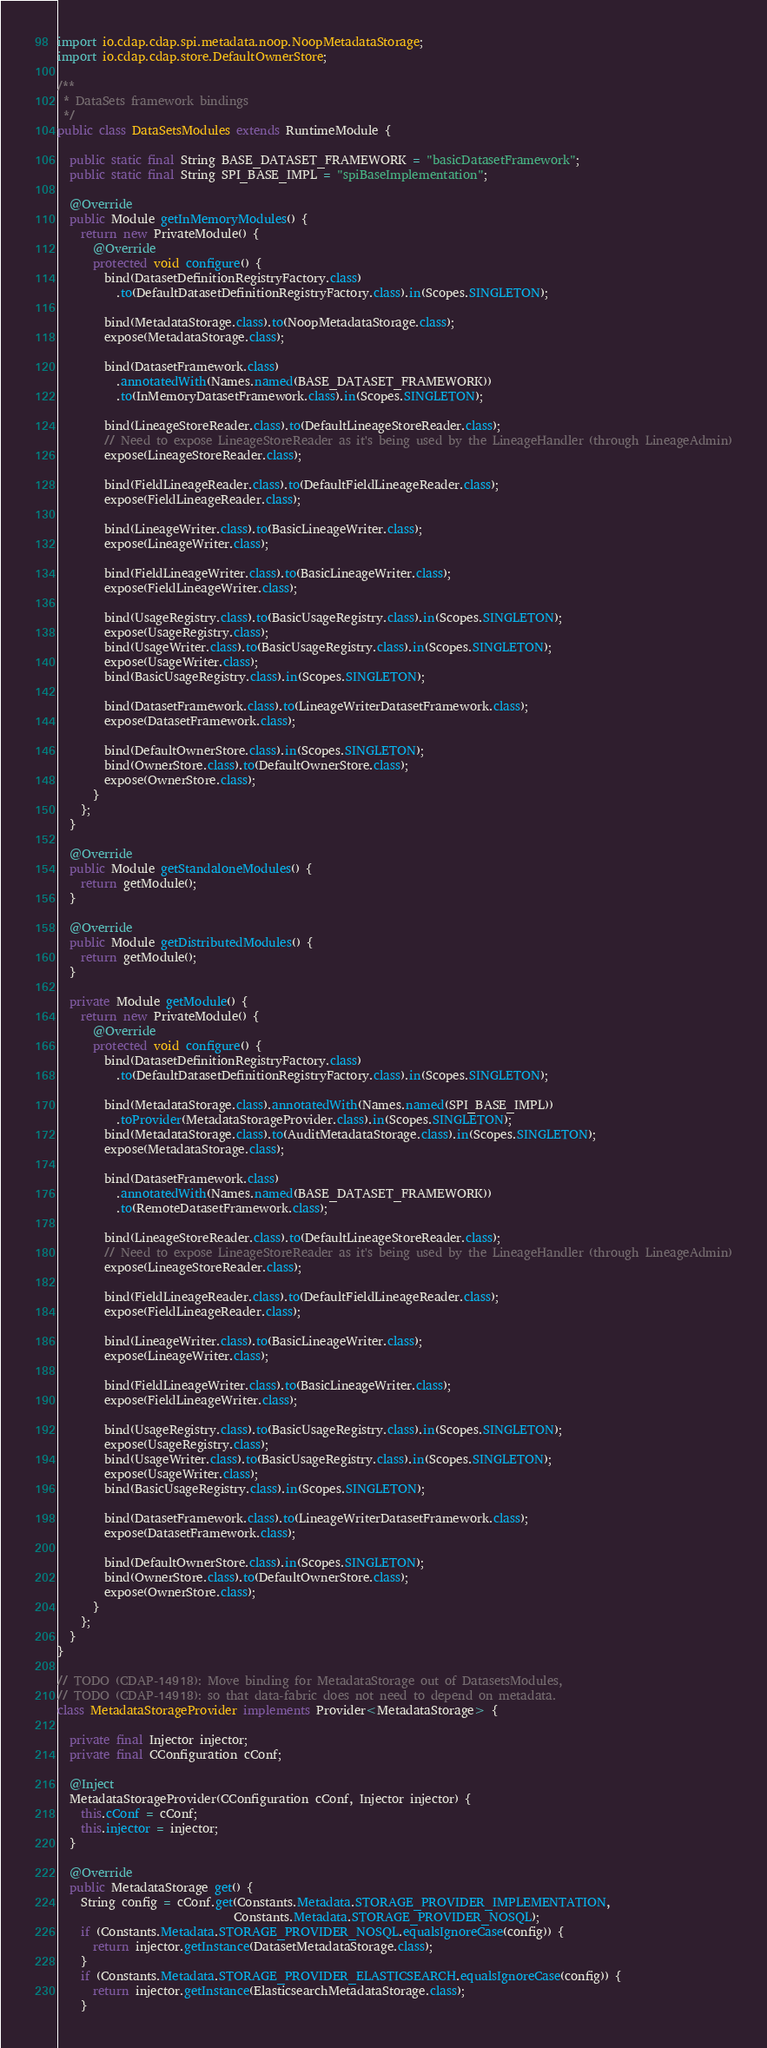Convert code to text. <code><loc_0><loc_0><loc_500><loc_500><_Java_>import io.cdap.cdap.spi.metadata.noop.NoopMetadataStorage;
import io.cdap.cdap.store.DefaultOwnerStore;

/**
 * DataSets framework bindings
 */
public class DataSetsModules extends RuntimeModule {

  public static final String BASE_DATASET_FRAMEWORK = "basicDatasetFramework";
  public static final String SPI_BASE_IMPL = "spiBaseImplementation";

  @Override
  public Module getInMemoryModules() {
    return new PrivateModule() {
      @Override
      protected void configure() {
        bind(DatasetDefinitionRegistryFactory.class)
          .to(DefaultDatasetDefinitionRegistryFactory.class).in(Scopes.SINGLETON);

        bind(MetadataStorage.class).to(NoopMetadataStorage.class);
        expose(MetadataStorage.class);

        bind(DatasetFramework.class)
          .annotatedWith(Names.named(BASE_DATASET_FRAMEWORK))
          .to(InMemoryDatasetFramework.class).in(Scopes.SINGLETON);

        bind(LineageStoreReader.class).to(DefaultLineageStoreReader.class);
        // Need to expose LineageStoreReader as it's being used by the LineageHandler (through LineageAdmin)
        expose(LineageStoreReader.class);

        bind(FieldLineageReader.class).to(DefaultFieldLineageReader.class);
        expose(FieldLineageReader.class);

        bind(LineageWriter.class).to(BasicLineageWriter.class);
        expose(LineageWriter.class);

        bind(FieldLineageWriter.class).to(BasicLineageWriter.class);
        expose(FieldLineageWriter.class);

        bind(UsageRegistry.class).to(BasicUsageRegistry.class).in(Scopes.SINGLETON);
        expose(UsageRegistry.class);
        bind(UsageWriter.class).to(BasicUsageRegistry.class).in(Scopes.SINGLETON);
        expose(UsageWriter.class);
        bind(BasicUsageRegistry.class).in(Scopes.SINGLETON);

        bind(DatasetFramework.class).to(LineageWriterDatasetFramework.class);
        expose(DatasetFramework.class);

        bind(DefaultOwnerStore.class).in(Scopes.SINGLETON);
        bind(OwnerStore.class).to(DefaultOwnerStore.class);
        expose(OwnerStore.class);
      }
    };
  }

  @Override
  public Module getStandaloneModules() {
    return getModule();
  }

  @Override
  public Module getDistributedModules() {
    return getModule();
  }

  private Module getModule() {
    return new PrivateModule() {
      @Override
      protected void configure() {
        bind(DatasetDefinitionRegistryFactory.class)
          .to(DefaultDatasetDefinitionRegistryFactory.class).in(Scopes.SINGLETON);

        bind(MetadataStorage.class).annotatedWith(Names.named(SPI_BASE_IMPL))
          .toProvider(MetadataStorageProvider.class).in(Scopes.SINGLETON);
        bind(MetadataStorage.class).to(AuditMetadataStorage.class).in(Scopes.SINGLETON);
        expose(MetadataStorage.class);

        bind(DatasetFramework.class)
          .annotatedWith(Names.named(BASE_DATASET_FRAMEWORK))
          .to(RemoteDatasetFramework.class);

        bind(LineageStoreReader.class).to(DefaultLineageStoreReader.class);
        // Need to expose LineageStoreReader as it's being used by the LineageHandler (through LineageAdmin)
        expose(LineageStoreReader.class);

        bind(FieldLineageReader.class).to(DefaultFieldLineageReader.class);
        expose(FieldLineageReader.class);

        bind(LineageWriter.class).to(BasicLineageWriter.class);
        expose(LineageWriter.class);

        bind(FieldLineageWriter.class).to(BasicLineageWriter.class);
        expose(FieldLineageWriter.class);

        bind(UsageRegistry.class).to(BasicUsageRegistry.class).in(Scopes.SINGLETON);
        expose(UsageRegistry.class);
        bind(UsageWriter.class).to(BasicUsageRegistry.class).in(Scopes.SINGLETON);
        expose(UsageWriter.class);
        bind(BasicUsageRegistry.class).in(Scopes.SINGLETON);

        bind(DatasetFramework.class).to(LineageWriterDatasetFramework.class);
        expose(DatasetFramework.class);

        bind(DefaultOwnerStore.class).in(Scopes.SINGLETON);
        bind(OwnerStore.class).to(DefaultOwnerStore.class);
        expose(OwnerStore.class);
      }
    };
  }
}

// TODO (CDAP-14918): Move binding for MetadataStorage out of DatasetsModules,
// TODO (CDAP-14918): so that data-fabric does not need to depend on metadata.
class MetadataStorageProvider implements Provider<MetadataStorage> {

  private final Injector injector;
  private final CConfiguration cConf;

  @Inject
  MetadataStorageProvider(CConfiguration cConf, Injector injector) {
    this.cConf = cConf;
    this.injector = injector;
  }

  @Override
  public MetadataStorage get() {
    String config = cConf.get(Constants.Metadata.STORAGE_PROVIDER_IMPLEMENTATION,
                              Constants.Metadata.STORAGE_PROVIDER_NOSQL);
    if (Constants.Metadata.STORAGE_PROVIDER_NOSQL.equalsIgnoreCase(config)) {
      return injector.getInstance(DatasetMetadataStorage.class);
    }
    if (Constants.Metadata.STORAGE_PROVIDER_ELASTICSEARCH.equalsIgnoreCase(config)) {
      return injector.getInstance(ElasticsearchMetadataStorage.class);
    }</code> 